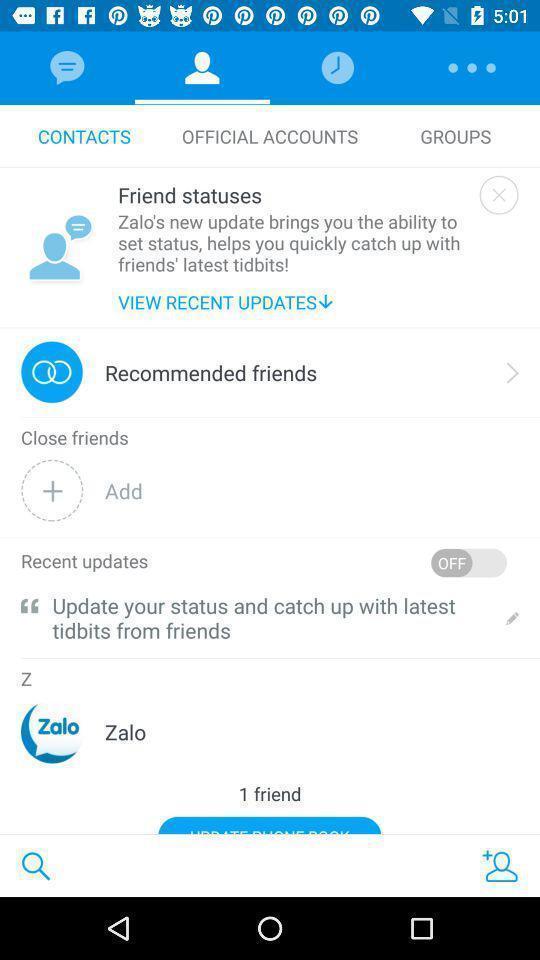Describe the content in this image. Page showing interface for a social media app. 